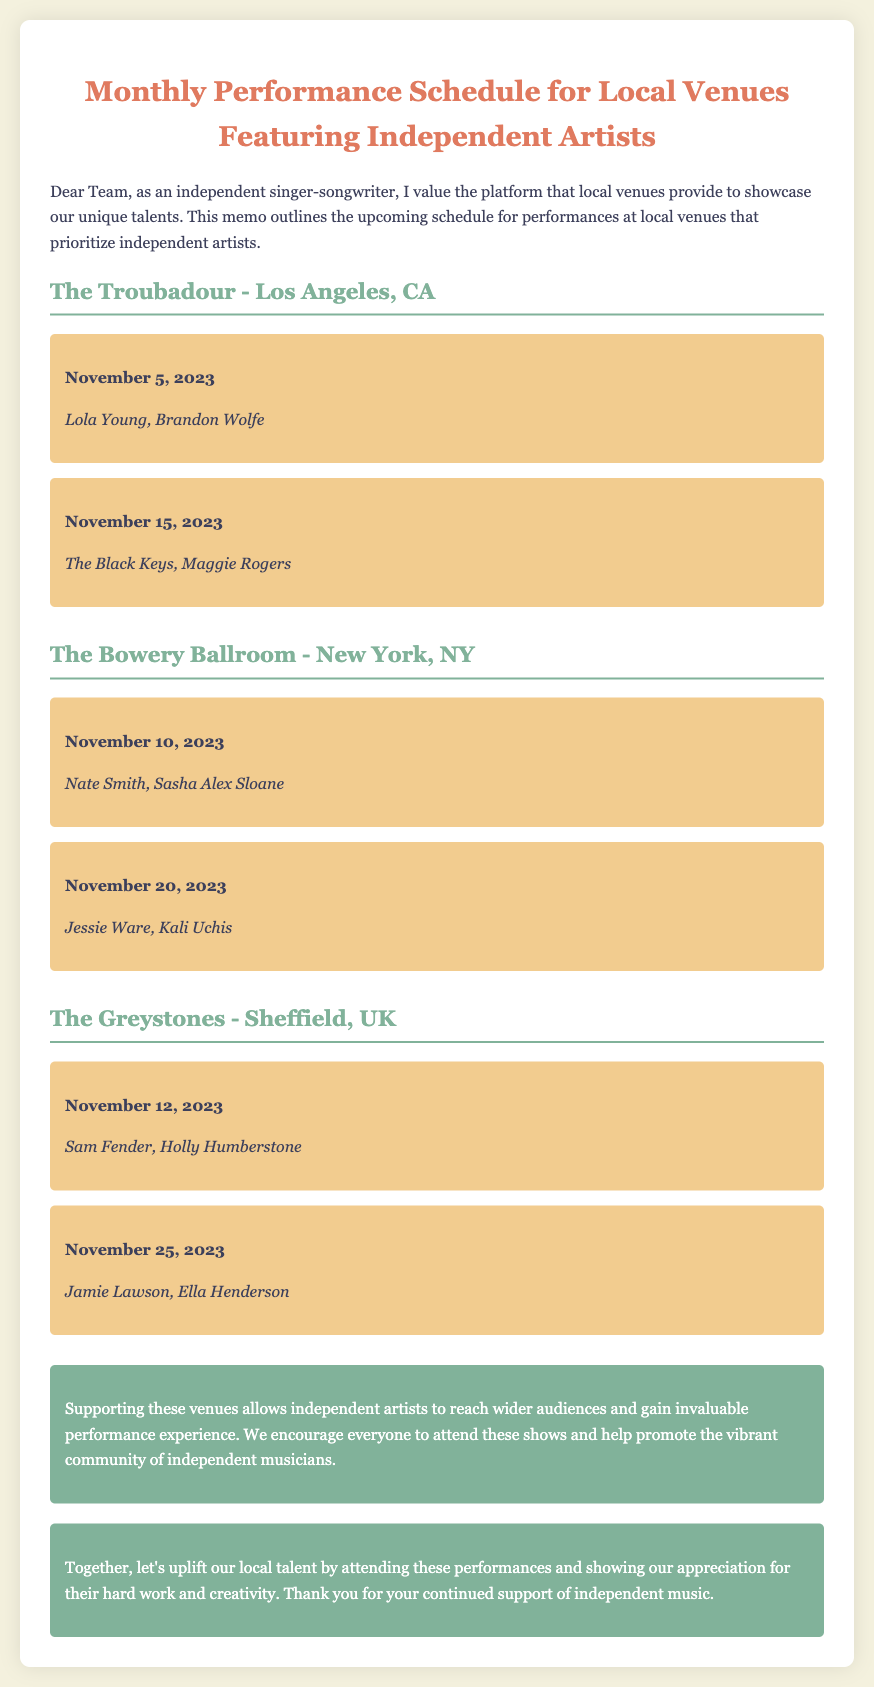What is the date of the performance by Lola Young? The date for Lola Young's performance at The Troubadour is specified in the memo as November 5, 2023.
Answer: November 5, 2023 Which venue hosts performances featuring Sam Fender? The memo lists The Greystones in Sheffield, UK as the venue for Sam Fender's performance.
Answer: The Greystones How many performances are scheduled at The Bowery Ballroom? The memo states that there are two performances scheduled at The Bowery Ballroom.
Answer: Two Who are the artists performing on November 20, 2023, at The Bowery Ballroom? The performance list for November 20, 2023, at The Bowery Ballroom includes Jessie Ware and Kali Uchis.
Answer: Jessie Ware, Kali Uchis What is the importance of supporting local venues according to the memo? The memo highlights that supporting local venues allows independent artists to reach wider audiences and gain performance experience.
Answer: Wider audiences and experience How many performances in total are listed for The Troubadour? The memo indicates that there are two performances scheduled at The Troubadour.
Answer: Two 